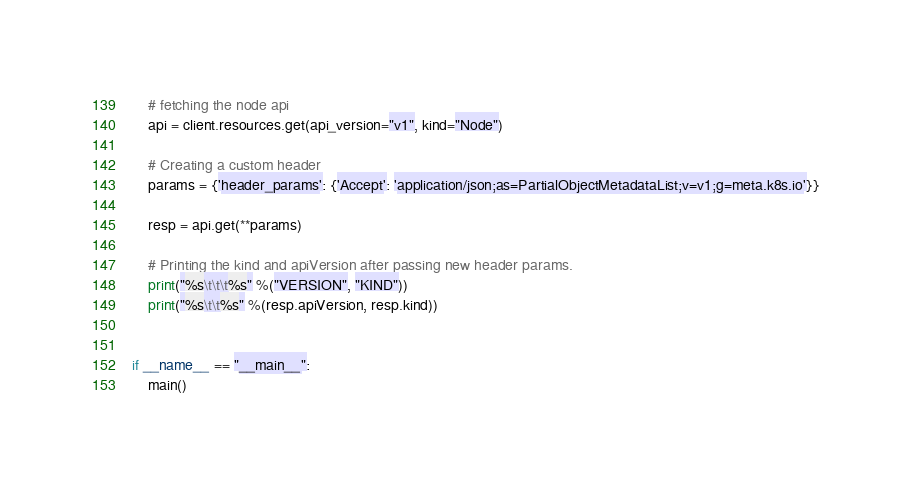<code> <loc_0><loc_0><loc_500><loc_500><_Python_>
    # fetching the node api
    api = client.resources.get(api_version="v1", kind="Node")

    # Creating a custom header
    params = {'header_params': {'Accept': 'application/json;as=PartialObjectMetadataList;v=v1;g=meta.k8s.io'}}

    resp = api.get(**params)

    # Printing the kind and apiVersion after passing new header params.
    print("%s\t\t\t%s" %("VERSION", "KIND"))
    print("%s\t\t%s" %(resp.apiVersion, resp.kind))


if __name__ == "__main__":
    main()</code> 